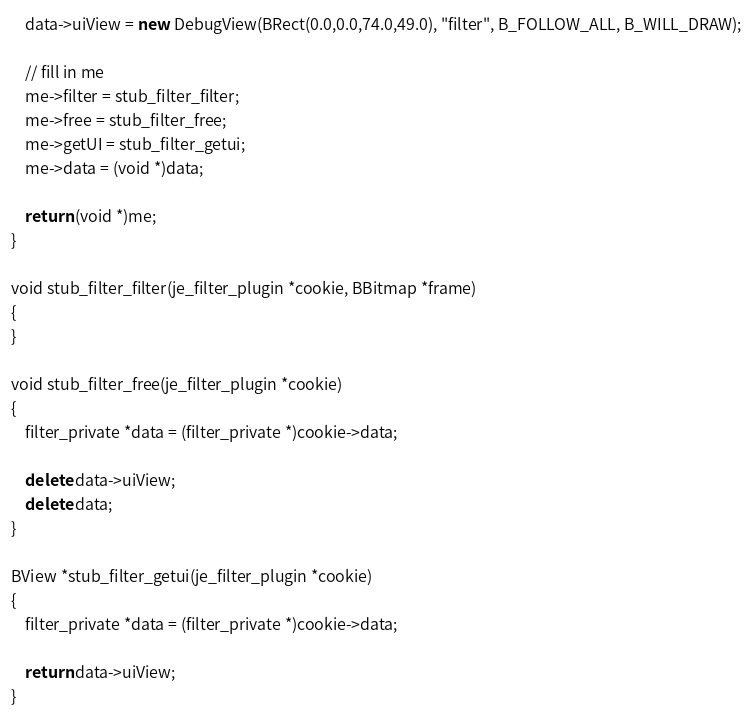Convert code to text. <code><loc_0><loc_0><loc_500><loc_500><_C++_>	data->uiView = new DebugView(BRect(0.0,0.0,74.0,49.0), "filter", B_FOLLOW_ALL, B_WILL_DRAW);
	
	// fill in me
	me->filter = stub_filter_filter;
	me->free = stub_filter_free;
	me->getUI = stub_filter_getui;
	me->data = (void *)data;
	
	return (void *)me;
}

void stub_filter_filter(je_filter_plugin *cookie, BBitmap *frame)
{
}

void stub_filter_free(je_filter_plugin *cookie)
{
	filter_private *data = (filter_private *)cookie->data;
	
	delete data->uiView;
	delete data;
}

BView *stub_filter_getui(je_filter_plugin *cookie)
{
	filter_private *data = (filter_private *)cookie->data;
	
	return data->uiView;
}
</code> 